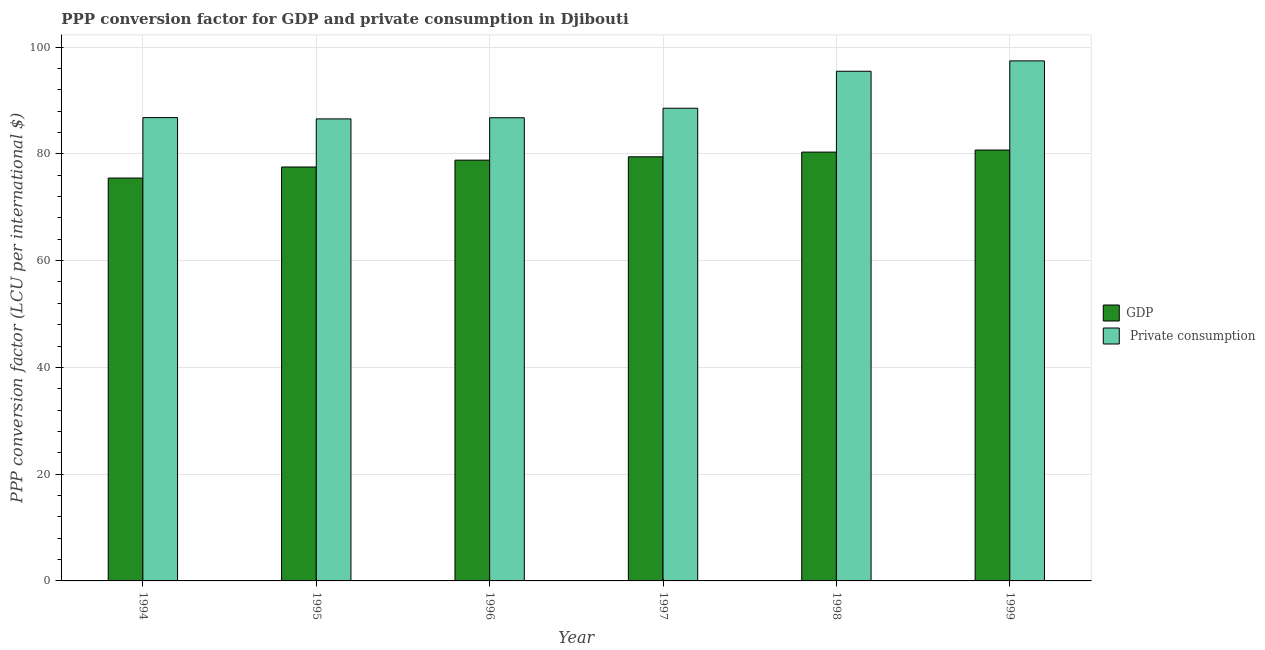How many different coloured bars are there?
Your response must be concise. 2. How many groups of bars are there?
Your answer should be very brief. 6. Are the number of bars per tick equal to the number of legend labels?
Your answer should be very brief. Yes. Are the number of bars on each tick of the X-axis equal?
Ensure brevity in your answer.  Yes. How many bars are there on the 1st tick from the left?
Ensure brevity in your answer.  2. How many bars are there on the 6th tick from the right?
Ensure brevity in your answer.  2. What is the label of the 2nd group of bars from the left?
Provide a succinct answer. 1995. What is the ppp conversion factor for gdp in 1997?
Provide a short and direct response. 79.45. Across all years, what is the maximum ppp conversion factor for gdp?
Your answer should be compact. 80.72. Across all years, what is the minimum ppp conversion factor for private consumption?
Ensure brevity in your answer.  86.55. What is the total ppp conversion factor for private consumption in the graph?
Provide a short and direct response. 541.55. What is the difference between the ppp conversion factor for gdp in 1994 and that in 1996?
Keep it short and to the point. -3.36. What is the difference between the ppp conversion factor for gdp in 1995 and the ppp conversion factor for private consumption in 1998?
Provide a succinct answer. -2.79. What is the average ppp conversion factor for gdp per year?
Your response must be concise. 78.72. In how many years, is the ppp conversion factor for gdp greater than 92 LCU?
Offer a very short reply. 0. What is the ratio of the ppp conversion factor for gdp in 1994 to that in 1997?
Your answer should be compact. 0.95. Is the difference between the ppp conversion factor for gdp in 1996 and 1999 greater than the difference between the ppp conversion factor for private consumption in 1996 and 1999?
Make the answer very short. No. What is the difference between the highest and the second highest ppp conversion factor for private consumption?
Keep it short and to the point. 1.95. What is the difference between the highest and the lowest ppp conversion factor for gdp?
Provide a succinct answer. 5.25. What does the 2nd bar from the left in 1999 represents?
Keep it short and to the point.  Private consumption. What does the 1st bar from the right in 1997 represents?
Your response must be concise.  Private consumption. What is the difference between two consecutive major ticks on the Y-axis?
Your answer should be compact. 20. Are the values on the major ticks of Y-axis written in scientific E-notation?
Your answer should be compact. No. Does the graph contain grids?
Offer a terse response. Yes. Where does the legend appear in the graph?
Make the answer very short. Center right. How are the legend labels stacked?
Make the answer very short. Vertical. What is the title of the graph?
Your response must be concise. PPP conversion factor for GDP and private consumption in Djibouti. What is the label or title of the X-axis?
Your answer should be very brief. Year. What is the label or title of the Y-axis?
Offer a terse response. PPP conversion factor (LCU per international $). What is the PPP conversion factor (LCU per international $) of GDP in 1994?
Offer a terse response. 75.47. What is the PPP conversion factor (LCU per international $) in  Private consumption in 1994?
Ensure brevity in your answer.  86.79. What is the PPP conversion factor (LCU per international $) in GDP in 1995?
Your response must be concise. 77.54. What is the PPP conversion factor (LCU per international $) in  Private consumption in 1995?
Give a very brief answer. 86.55. What is the PPP conversion factor (LCU per international $) in GDP in 1996?
Your answer should be very brief. 78.82. What is the PPP conversion factor (LCU per international $) of  Private consumption in 1996?
Make the answer very short. 86.77. What is the PPP conversion factor (LCU per international $) of GDP in 1997?
Provide a short and direct response. 79.45. What is the PPP conversion factor (LCU per international $) in  Private consumption in 1997?
Offer a very short reply. 88.55. What is the PPP conversion factor (LCU per international $) of GDP in 1998?
Offer a very short reply. 80.33. What is the PPP conversion factor (LCU per international $) in  Private consumption in 1998?
Give a very brief answer. 95.47. What is the PPP conversion factor (LCU per international $) of GDP in 1999?
Your response must be concise. 80.72. What is the PPP conversion factor (LCU per international $) in  Private consumption in 1999?
Provide a short and direct response. 97.42. Across all years, what is the maximum PPP conversion factor (LCU per international $) of GDP?
Offer a terse response. 80.72. Across all years, what is the maximum PPP conversion factor (LCU per international $) of  Private consumption?
Your response must be concise. 97.42. Across all years, what is the minimum PPP conversion factor (LCU per international $) of GDP?
Keep it short and to the point. 75.47. Across all years, what is the minimum PPP conversion factor (LCU per international $) in  Private consumption?
Your answer should be compact. 86.55. What is the total PPP conversion factor (LCU per international $) in GDP in the graph?
Your response must be concise. 472.33. What is the total PPP conversion factor (LCU per international $) in  Private consumption in the graph?
Provide a succinct answer. 541.55. What is the difference between the PPP conversion factor (LCU per international $) in GDP in 1994 and that in 1995?
Your answer should be very brief. -2.07. What is the difference between the PPP conversion factor (LCU per international $) of  Private consumption in 1994 and that in 1995?
Your answer should be very brief. 0.24. What is the difference between the PPP conversion factor (LCU per international $) of GDP in 1994 and that in 1996?
Ensure brevity in your answer.  -3.36. What is the difference between the PPP conversion factor (LCU per international $) in  Private consumption in 1994 and that in 1996?
Provide a succinct answer. 0.03. What is the difference between the PPP conversion factor (LCU per international $) of GDP in 1994 and that in 1997?
Keep it short and to the point. -3.98. What is the difference between the PPP conversion factor (LCU per international $) in  Private consumption in 1994 and that in 1997?
Offer a terse response. -1.76. What is the difference between the PPP conversion factor (LCU per international $) in GDP in 1994 and that in 1998?
Make the answer very short. -4.86. What is the difference between the PPP conversion factor (LCU per international $) in  Private consumption in 1994 and that in 1998?
Give a very brief answer. -8.68. What is the difference between the PPP conversion factor (LCU per international $) of GDP in 1994 and that in 1999?
Offer a terse response. -5.25. What is the difference between the PPP conversion factor (LCU per international $) in  Private consumption in 1994 and that in 1999?
Your answer should be compact. -10.63. What is the difference between the PPP conversion factor (LCU per international $) of GDP in 1995 and that in 1996?
Give a very brief answer. -1.28. What is the difference between the PPP conversion factor (LCU per international $) in  Private consumption in 1995 and that in 1996?
Ensure brevity in your answer.  -0.22. What is the difference between the PPP conversion factor (LCU per international $) in GDP in 1995 and that in 1997?
Your answer should be very brief. -1.91. What is the difference between the PPP conversion factor (LCU per international $) of  Private consumption in 1995 and that in 1997?
Your answer should be compact. -2. What is the difference between the PPP conversion factor (LCU per international $) in GDP in 1995 and that in 1998?
Your answer should be compact. -2.79. What is the difference between the PPP conversion factor (LCU per international $) of  Private consumption in 1995 and that in 1998?
Your answer should be very brief. -8.92. What is the difference between the PPP conversion factor (LCU per international $) in GDP in 1995 and that in 1999?
Give a very brief answer. -3.18. What is the difference between the PPP conversion factor (LCU per international $) in  Private consumption in 1995 and that in 1999?
Your answer should be very brief. -10.87. What is the difference between the PPP conversion factor (LCU per international $) in GDP in 1996 and that in 1997?
Keep it short and to the point. -0.63. What is the difference between the PPP conversion factor (LCU per international $) of  Private consumption in 1996 and that in 1997?
Provide a succinct answer. -1.78. What is the difference between the PPP conversion factor (LCU per international $) in GDP in 1996 and that in 1998?
Offer a terse response. -1.51. What is the difference between the PPP conversion factor (LCU per international $) in  Private consumption in 1996 and that in 1998?
Your answer should be compact. -8.71. What is the difference between the PPP conversion factor (LCU per international $) of GDP in 1996 and that in 1999?
Provide a short and direct response. -1.89. What is the difference between the PPP conversion factor (LCU per international $) of  Private consumption in 1996 and that in 1999?
Your response must be concise. -10.65. What is the difference between the PPP conversion factor (LCU per international $) in GDP in 1997 and that in 1998?
Your answer should be compact. -0.88. What is the difference between the PPP conversion factor (LCU per international $) in  Private consumption in 1997 and that in 1998?
Your answer should be compact. -6.92. What is the difference between the PPP conversion factor (LCU per international $) in GDP in 1997 and that in 1999?
Give a very brief answer. -1.27. What is the difference between the PPP conversion factor (LCU per international $) in  Private consumption in 1997 and that in 1999?
Make the answer very short. -8.87. What is the difference between the PPP conversion factor (LCU per international $) in GDP in 1998 and that in 1999?
Give a very brief answer. -0.39. What is the difference between the PPP conversion factor (LCU per international $) of  Private consumption in 1998 and that in 1999?
Your answer should be very brief. -1.95. What is the difference between the PPP conversion factor (LCU per international $) in GDP in 1994 and the PPP conversion factor (LCU per international $) in  Private consumption in 1995?
Your answer should be compact. -11.08. What is the difference between the PPP conversion factor (LCU per international $) of GDP in 1994 and the PPP conversion factor (LCU per international $) of  Private consumption in 1996?
Ensure brevity in your answer.  -11.3. What is the difference between the PPP conversion factor (LCU per international $) of GDP in 1994 and the PPP conversion factor (LCU per international $) of  Private consumption in 1997?
Offer a very short reply. -13.08. What is the difference between the PPP conversion factor (LCU per international $) in GDP in 1994 and the PPP conversion factor (LCU per international $) in  Private consumption in 1998?
Your answer should be compact. -20. What is the difference between the PPP conversion factor (LCU per international $) of GDP in 1994 and the PPP conversion factor (LCU per international $) of  Private consumption in 1999?
Provide a short and direct response. -21.95. What is the difference between the PPP conversion factor (LCU per international $) in GDP in 1995 and the PPP conversion factor (LCU per international $) in  Private consumption in 1996?
Provide a short and direct response. -9.23. What is the difference between the PPP conversion factor (LCU per international $) in GDP in 1995 and the PPP conversion factor (LCU per international $) in  Private consumption in 1997?
Your response must be concise. -11.01. What is the difference between the PPP conversion factor (LCU per international $) in GDP in 1995 and the PPP conversion factor (LCU per international $) in  Private consumption in 1998?
Offer a terse response. -17.93. What is the difference between the PPP conversion factor (LCU per international $) in GDP in 1995 and the PPP conversion factor (LCU per international $) in  Private consumption in 1999?
Provide a succinct answer. -19.88. What is the difference between the PPP conversion factor (LCU per international $) of GDP in 1996 and the PPP conversion factor (LCU per international $) of  Private consumption in 1997?
Provide a succinct answer. -9.73. What is the difference between the PPP conversion factor (LCU per international $) of GDP in 1996 and the PPP conversion factor (LCU per international $) of  Private consumption in 1998?
Provide a succinct answer. -16.65. What is the difference between the PPP conversion factor (LCU per international $) of GDP in 1996 and the PPP conversion factor (LCU per international $) of  Private consumption in 1999?
Provide a succinct answer. -18.6. What is the difference between the PPP conversion factor (LCU per international $) of GDP in 1997 and the PPP conversion factor (LCU per international $) of  Private consumption in 1998?
Offer a terse response. -16.02. What is the difference between the PPP conversion factor (LCU per international $) of GDP in 1997 and the PPP conversion factor (LCU per international $) of  Private consumption in 1999?
Give a very brief answer. -17.97. What is the difference between the PPP conversion factor (LCU per international $) of GDP in 1998 and the PPP conversion factor (LCU per international $) of  Private consumption in 1999?
Provide a succinct answer. -17.09. What is the average PPP conversion factor (LCU per international $) of GDP per year?
Make the answer very short. 78.72. What is the average PPP conversion factor (LCU per international $) in  Private consumption per year?
Ensure brevity in your answer.  90.26. In the year 1994, what is the difference between the PPP conversion factor (LCU per international $) in GDP and PPP conversion factor (LCU per international $) in  Private consumption?
Ensure brevity in your answer.  -11.32. In the year 1995, what is the difference between the PPP conversion factor (LCU per international $) of GDP and PPP conversion factor (LCU per international $) of  Private consumption?
Make the answer very short. -9.01. In the year 1996, what is the difference between the PPP conversion factor (LCU per international $) of GDP and PPP conversion factor (LCU per international $) of  Private consumption?
Keep it short and to the point. -7.94. In the year 1997, what is the difference between the PPP conversion factor (LCU per international $) in GDP and PPP conversion factor (LCU per international $) in  Private consumption?
Offer a very short reply. -9.1. In the year 1998, what is the difference between the PPP conversion factor (LCU per international $) of GDP and PPP conversion factor (LCU per international $) of  Private consumption?
Keep it short and to the point. -15.14. In the year 1999, what is the difference between the PPP conversion factor (LCU per international $) in GDP and PPP conversion factor (LCU per international $) in  Private consumption?
Make the answer very short. -16.7. What is the ratio of the PPP conversion factor (LCU per international $) of GDP in 1994 to that in 1995?
Provide a short and direct response. 0.97. What is the ratio of the PPP conversion factor (LCU per international $) of  Private consumption in 1994 to that in 1995?
Your response must be concise. 1. What is the ratio of the PPP conversion factor (LCU per international $) of GDP in 1994 to that in 1996?
Your response must be concise. 0.96. What is the ratio of the PPP conversion factor (LCU per international $) of  Private consumption in 1994 to that in 1996?
Your answer should be compact. 1. What is the ratio of the PPP conversion factor (LCU per international $) of GDP in 1994 to that in 1997?
Provide a succinct answer. 0.95. What is the ratio of the PPP conversion factor (LCU per international $) in  Private consumption in 1994 to that in 1997?
Offer a very short reply. 0.98. What is the ratio of the PPP conversion factor (LCU per international $) of GDP in 1994 to that in 1998?
Provide a succinct answer. 0.94. What is the ratio of the PPP conversion factor (LCU per international $) of GDP in 1994 to that in 1999?
Offer a terse response. 0.94. What is the ratio of the PPP conversion factor (LCU per international $) of  Private consumption in 1994 to that in 1999?
Your response must be concise. 0.89. What is the ratio of the PPP conversion factor (LCU per international $) in GDP in 1995 to that in 1996?
Offer a very short reply. 0.98. What is the ratio of the PPP conversion factor (LCU per international $) in  Private consumption in 1995 to that in 1996?
Keep it short and to the point. 1. What is the ratio of the PPP conversion factor (LCU per international $) in GDP in 1995 to that in 1997?
Offer a terse response. 0.98. What is the ratio of the PPP conversion factor (LCU per international $) of  Private consumption in 1995 to that in 1997?
Make the answer very short. 0.98. What is the ratio of the PPP conversion factor (LCU per international $) of GDP in 1995 to that in 1998?
Provide a short and direct response. 0.97. What is the ratio of the PPP conversion factor (LCU per international $) in  Private consumption in 1995 to that in 1998?
Your answer should be compact. 0.91. What is the ratio of the PPP conversion factor (LCU per international $) of GDP in 1995 to that in 1999?
Your answer should be very brief. 0.96. What is the ratio of the PPP conversion factor (LCU per international $) of  Private consumption in 1995 to that in 1999?
Your answer should be very brief. 0.89. What is the ratio of the PPP conversion factor (LCU per international $) in GDP in 1996 to that in 1997?
Give a very brief answer. 0.99. What is the ratio of the PPP conversion factor (LCU per international $) in  Private consumption in 1996 to that in 1997?
Provide a succinct answer. 0.98. What is the ratio of the PPP conversion factor (LCU per international $) of GDP in 1996 to that in 1998?
Offer a terse response. 0.98. What is the ratio of the PPP conversion factor (LCU per international $) in  Private consumption in 1996 to that in 1998?
Offer a terse response. 0.91. What is the ratio of the PPP conversion factor (LCU per international $) in GDP in 1996 to that in 1999?
Ensure brevity in your answer.  0.98. What is the ratio of the PPP conversion factor (LCU per international $) of  Private consumption in 1996 to that in 1999?
Your response must be concise. 0.89. What is the ratio of the PPP conversion factor (LCU per international $) in  Private consumption in 1997 to that in 1998?
Your response must be concise. 0.93. What is the ratio of the PPP conversion factor (LCU per international $) in GDP in 1997 to that in 1999?
Your response must be concise. 0.98. What is the ratio of the PPP conversion factor (LCU per international $) of  Private consumption in 1997 to that in 1999?
Keep it short and to the point. 0.91. What is the ratio of the PPP conversion factor (LCU per international $) of GDP in 1998 to that in 1999?
Offer a very short reply. 1. What is the ratio of the PPP conversion factor (LCU per international $) in  Private consumption in 1998 to that in 1999?
Your answer should be very brief. 0.98. What is the difference between the highest and the second highest PPP conversion factor (LCU per international $) in GDP?
Provide a succinct answer. 0.39. What is the difference between the highest and the second highest PPP conversion factor (LCU per international $) in  Private consumption?
Your response must be concise. 1.95. What is the difference between the highest and the lowest PPP conversion factor (LCU per international $) in GDP?
Offer a very short reply. 5.25. What is the difference between the highest and the lowest PPP conversion factor (LCU per international $) in  Private consumption?
Provide a succinct answer. 10.87. 